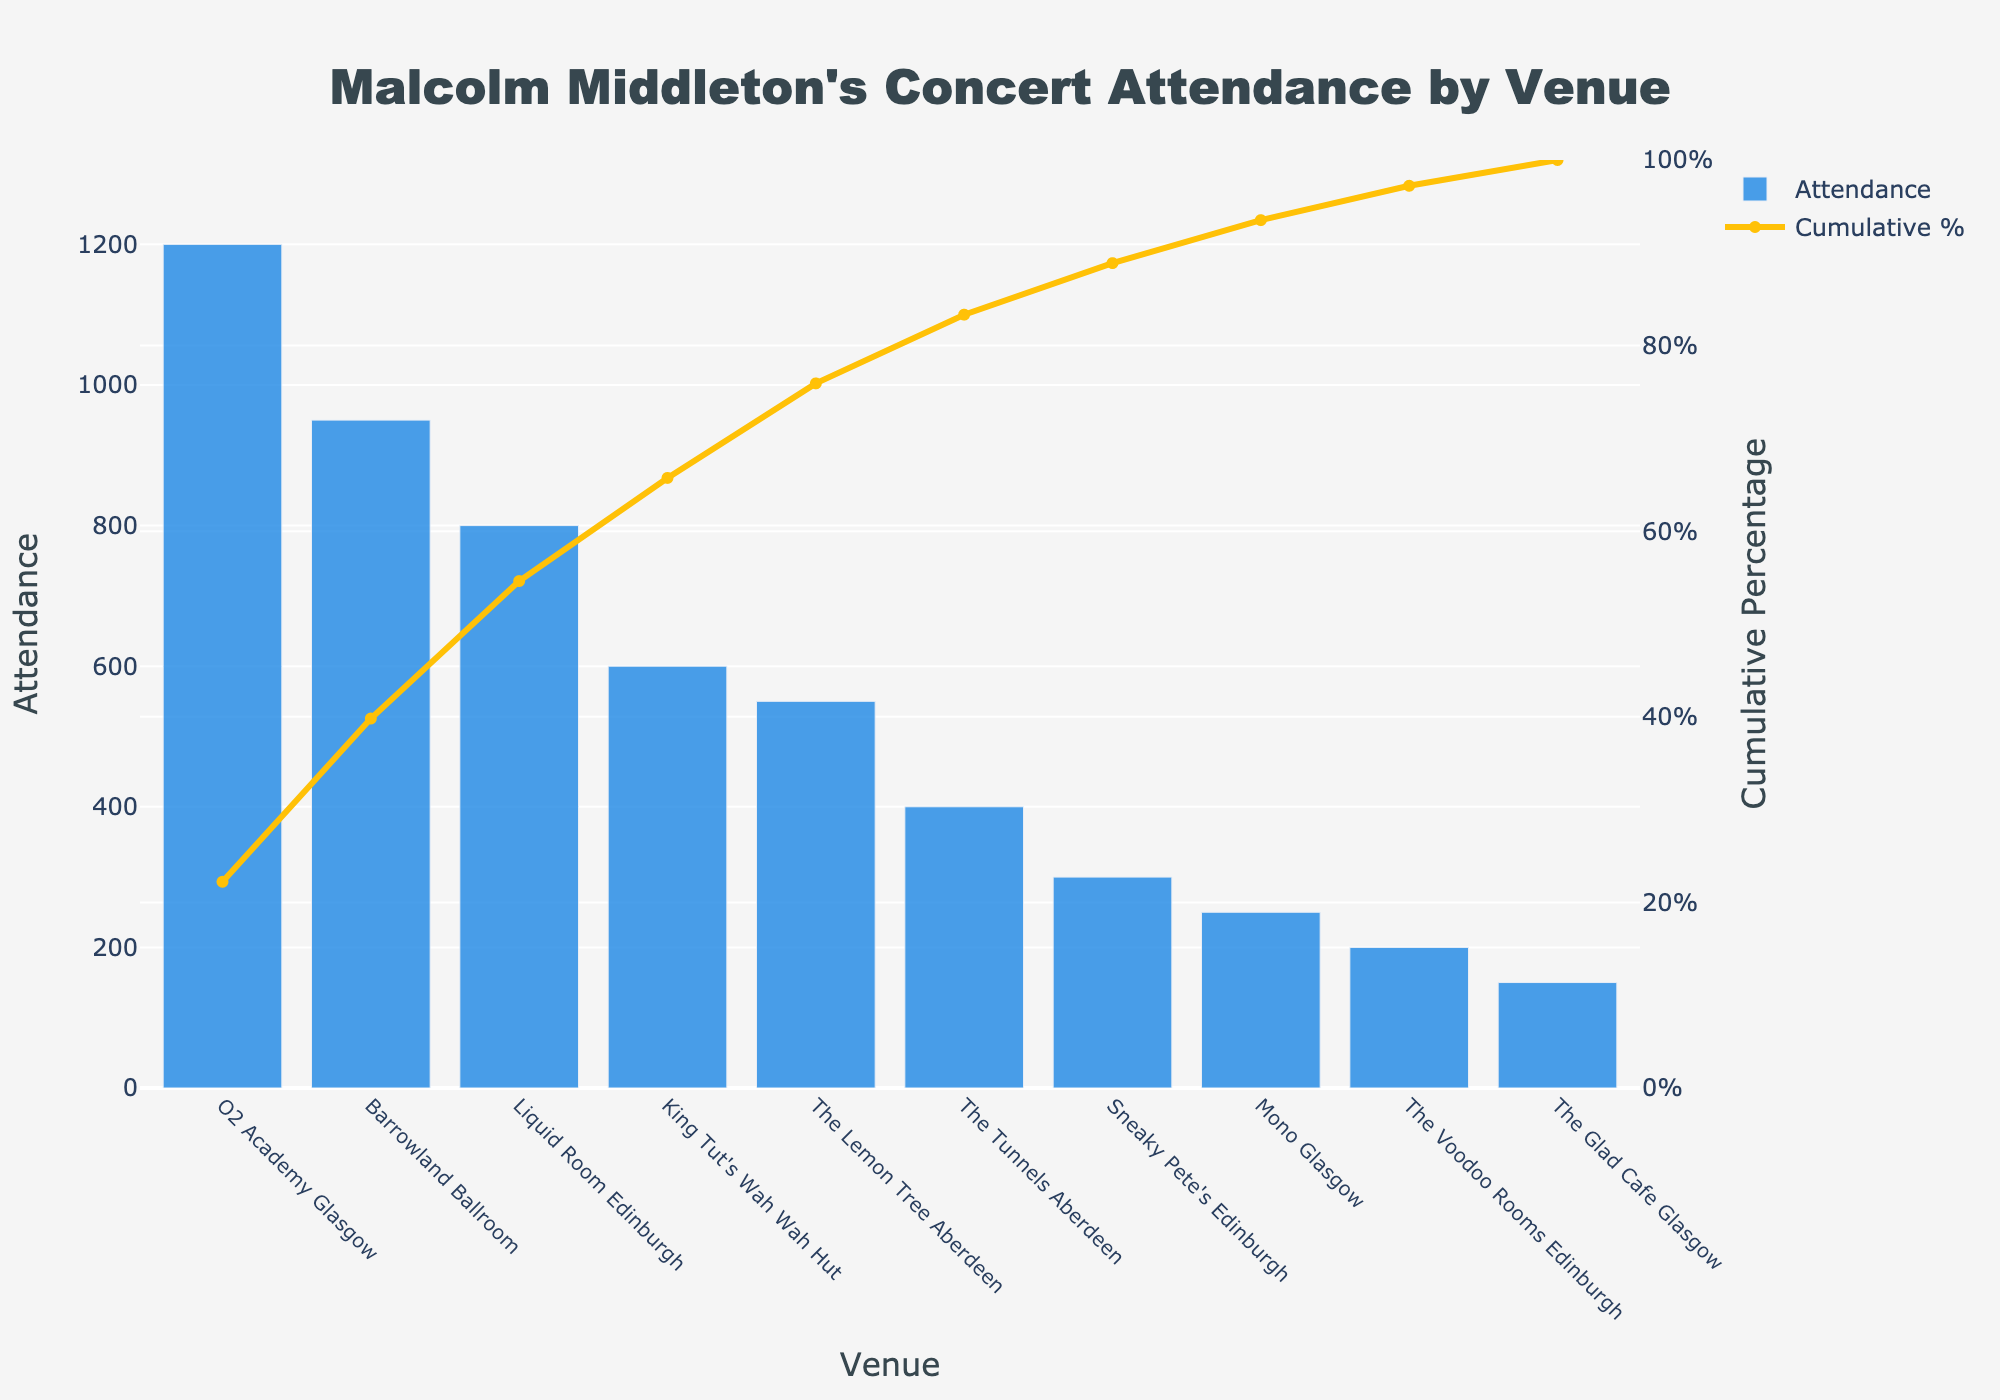What is the title of the plot? At the top of the figure, there is a text that describes the content of the plot.
Answer: Malcolm Middleton's Concert Attendance by Venue Which venue has the highest attendance? The highest bar represents the venue with the largest attendance.
Answer: O2 Academy Glasgow How many venues have an attendance of 600 or more? Identifying and counting the bars that extend to the 600 mark or higher helps determine this number.
Answer: 3 What's the cumulative percentage for The Tunnels Aberdeen? Locate The Tunnels Aberdeen on the x-axis and check the corresponding value on the cumulative percentage line.
Answer: Approximately 85% What is the attendance for the Barrowland Ballroom? Find the Barrowland Ballroom on the x-axis and check the height of the associated bar.
Answer: 950 What's the cumulative percentage after King Tut's Wah Wah Hut? Locate King Tut's Wah Wah Hut on the x-axis and observe the cumulative percentage line after this point.
Answer: Approximately 75% How do the attendances of The Lemon Tree Aberdeen and The Tunnels Aberdeen compare? Compare the heights of their bars to see which one is taller or shorter.
Answer: The Lemon Tree Aberdeen has a higher attendance Which venues contribute to the first 50% of the cumulative percentage? Follow the cumulative percentage line up to 50% and note the venues before this point.
Answer: O2 Academy Glasgow, Barrowland Ballroom, and Liquid Room Edinburgh What proportion of the total attendance has been accounted for by the time we reach Sneaky Pete's Edinburgh? Locate Sneaky Pete's Edinburgh on the x-axis and check the cumulative percentage value.
Answer: Approximately 87% What is the attendance for the smallest venue shown in the chart? Find the shortest bar and refer to its value on the y-axis.
Answer: 150 